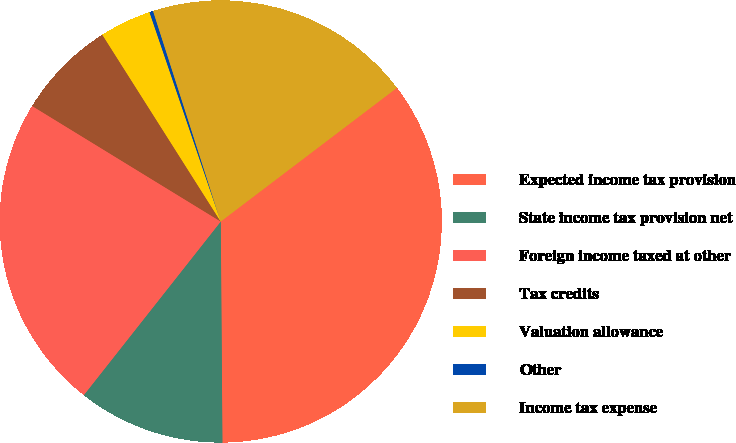Convert chart to OTSL. <chart><loc_0><loc_0><loc_500><loc_500><pie_chart><fcel>Expected income tax provision<fcel>State income tax provision net<fcel>Foreign income taxed at other<fcel>Tax credits<fcel>Valuation allowance<fcel>Other<fcel>Income tax expense<nl><fcel>35.21%<fcel>10.75%<fcel>23.12%<fcel>7.26%<fcel>3.77%<fcel>0.27%<fcel>19.62%<nl></chart> 